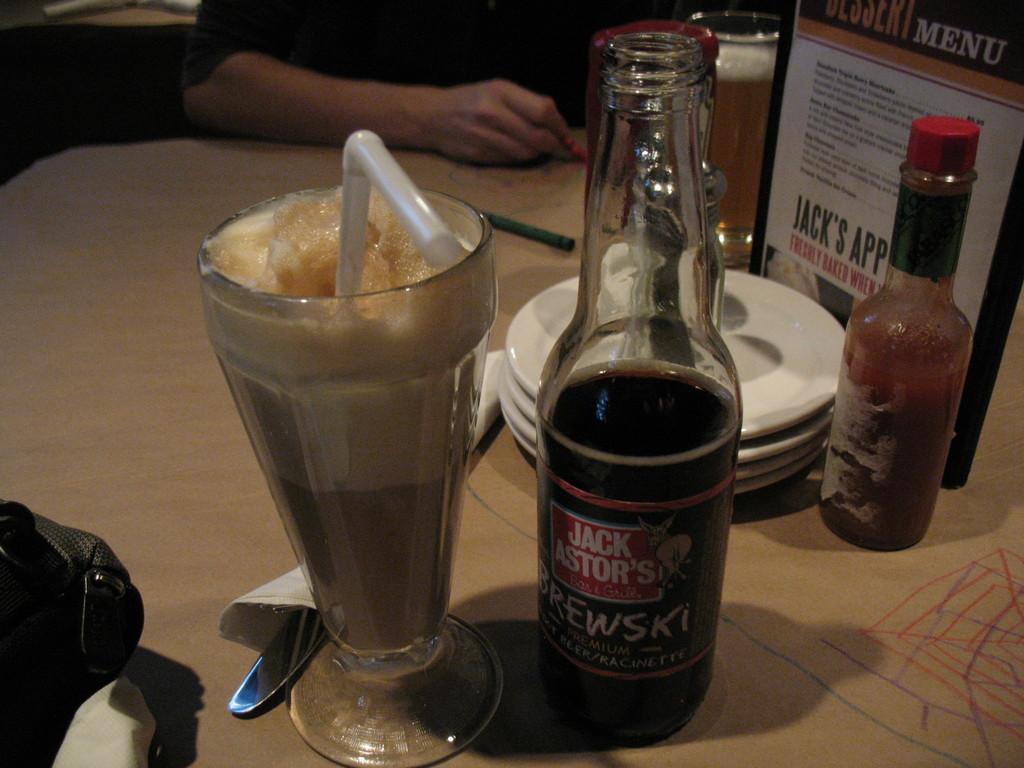What is the name of the drink?
Offer a very short reply. Jack astor's brewski. Which restaurant is this?
Offer a terse response. Jack astor's. 